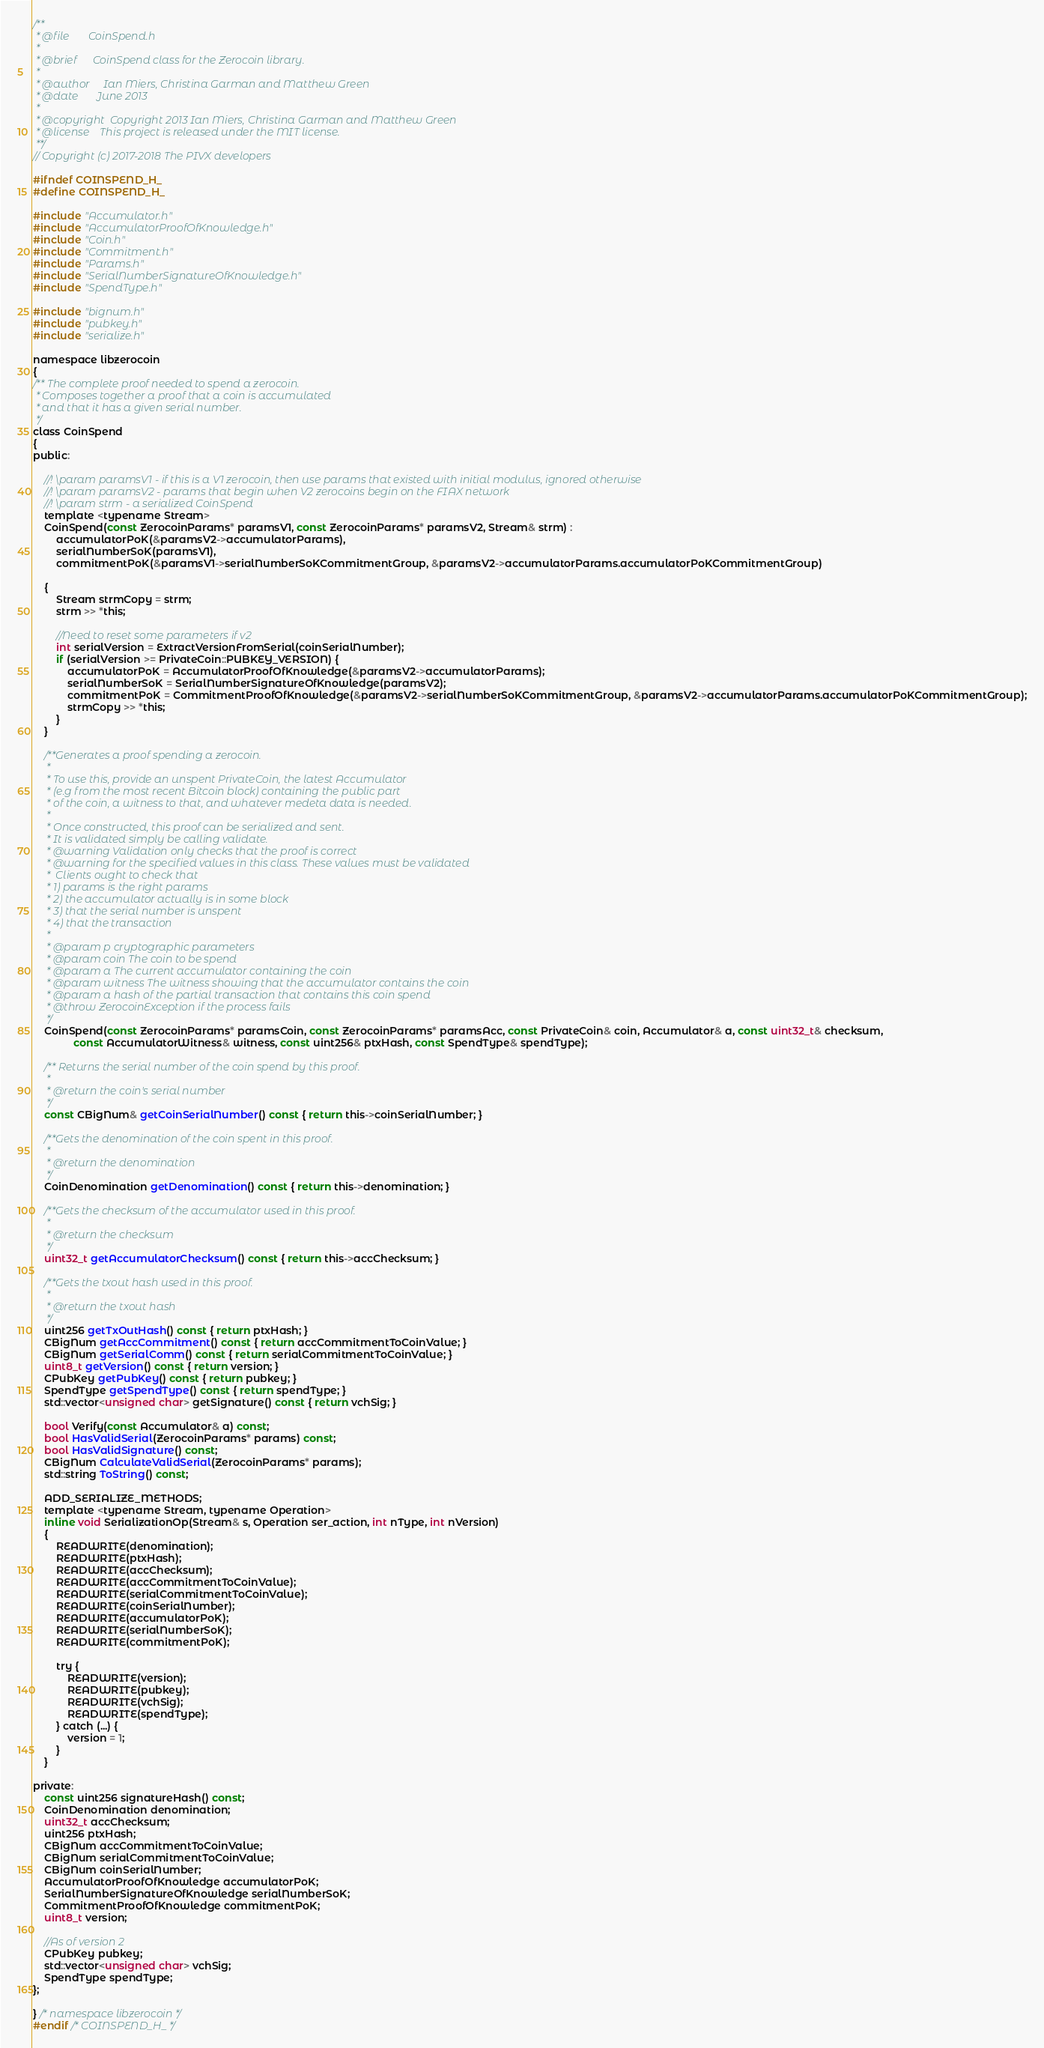Convert code to text. <code><loc_0><loc_0><loc_500><loc_500><_C_>/**
 * @file       CoinSpend.h
 *
 * @brief      CoinSpend class for the Zerocoin library.
 *
 * @author     Ian Miers, Christina Garman and Matthew Green
 * @date       June 2013
 *
 * @copyright  Copyright 2013 Ian Miers, Christina Garman and Matthew Green
 * @license    This project is released under the MIT license.
 **/
// Copyright (c) 2017-2018 The PIVX developers

#ifndef COINSPEND_H_
#define COINSPEND_H_

#include "Accumulator.h"
#include "AccumulatorProofOfKnowledge.h"
#include "Coin.h"
#include "Commitment.h"
#include "Params.h"
#include "SerialNumberSignatureOfKnowledge.h"
#include "SpendType.h"

#include "bignum.h"
#include "pubkey.h"
#include "serialize.h"

namespace libzerocoin
{
/** The complete proof needed to spend a zerocoin.
 * Composes together a proof that a coin is accumulated
 * and that it has a given serial number.
 */
class CoinSpend
{
public:

    //! \param paramsV1 - if this is a V1 zerocoin, then use params that existed with initial modulus, ignored otherwise
    //! \param paramsV2 - params that begin when V2 zerocoins begin on the FIAX network
    //! \param strm - a serialized CoinSpend
    template <typename Stream>
    CoinSpend(const ZerocoinParams* paramsV1, const ZerocoinParams* paramsV2, Stream& strm) :
        accumulatorPoK(&paramsV2->accumulatorParams),
        serialNumberSoK(paramsV1),
        commitmentPoK(&paramsV1->serialNumberSoKCommitmentGroup, &paramsV2->accumulatorParams.accumulatorPoKCommitmentGroup)

    {
        Stream strmCopy = strm;
        strm >> *this;

        //Need to reset some parameters if v2
        int serialVersion = ExtractVersionFromSerial(coinSerialNumber);
        if (serialVersion >= PrivateCoin::PUBKEY_VERSION) {
            accumulatorPoK = AccumulatorProofOfKnowledge(&paramsV2->accumulatorParams);
            serialNumberSoK = SerialNumberSignatureOfKnowledge(paramsV2);
            commitmentPoK = CommitmentProofOfKnowledge(&paramsV2->serialNumberSoKCommitmentGroup, &paramsV2->accumulatorParams.accumulatorPoKCommitmentGroup);
            strmCopy >> *this;
        }
    }

    /**Generates a proof spending a zerocoin.
	 *
	 * To use this, provide an unspent PrivateCoin, the latest Accumulator
	 * (e.g from the most recent Bitcoin block) containing the public part
	 * of the coin, a witness to that, and whatever medeta data is needed.
	 *
	 * Once constructed, this proof can be serialized and sent.
	 * It is validated simply be calling validate.
	 * @warning Validation only checks that the proof is correct
	 * @warning for the specified values in this class. These values must be validated
	 *  Clients ought to check that
	 * 1) params is the right params
	 * 2) the accumulator actually is in some block
	 * 3) that the serial number is unspent
	 * 4) that the transaction
	 *
	 * @param p cryptographic parameters
	 * @param coin The coin to be spend
	 * @param a The current accumulator containing the coin
	 * @param witness The witness showing that the accumulator contains the coin
	 * @param a hash of the partial transaction that contains this coin spend
	 * @throw ZerocoinException if the process fails
	 */
    CoinSpend(const ZerocoinParams* paramsCoin, const ZerocoinParams* paramsAcc, const PrivateCoin& coin, Accumulator& a, const uint32_t& checksum,
              const AccumulatorWitness& witness, const uint256& ptxHash, const SpendType& spendType);

    /** Returns the serial number of the coin spend by this proof.
	 *
	 * @return the coin's serial number
	 */
    const CBigNum& getCoinSerialNumber() const { return this->coinSerialNumber; }

    /**Gets the denomination of the coin spent in this proof.
	 *
	 * @return the denomination
	 */
    CoinDenomination getDenomination() const { return this->denomination; }

    /**Gets the checksum of the accumulator used in this proof.
	 *
	 * @return the checksum
	 */
    uint32_t getAccumulatorChecksum() const { return this->accChecksum; }

    /**Gets the txout hash used in this proof.
	 *
	 * @return the txout hash
	 */
    uint256 getTxOutHash() const { return ptxHash; }
    CBigNum getAccCommitment() const { return accCommitmentToCoinValue; }
    CBigNum getSerialComm() const { return serialCommitmentToCoinValue; }
    uint8_t getVersion() const { return version; }
    CPubKey getPubKey() const { return pubkey; }
    SpendType getSpendType() const { return spendType; }
    std::vector<unsigned char> getSignature() const { return vchSig; }

    bool Verify(const Accumulator& a) const;
    bool HasValidSerial(ZerocoinParams* params) const;
    bool HasValidSignature() const;
    CBigNum CalculateValidSerial(ZerocoinParams* params);
    std::string ToString() const;

    ADD_SERIALIZE_METHODS;
    template <typename Stream, typename Operation>
    inline void SerializationOp(Stream& s, Operation ser_action, int nType, int nVersion)
    {
        READWRITE(denomination);
        READWRITE(ptxHash);
        READWRITE(accChecksum);
        READWRITE(accCommitmentToCoinValue);
        READWRITE(serialCommitmentToCoinValue);
        READWRITE(coinSerialNumber);
        READWRITE(accumulatorPoK);
        READWRITE(serialNumberSoK);
        READWRITE(commitmentPoK);

        try {
            READWRITE(version);
            READWRITE(pubkey);
            READWRITE(vchSig);
            READWRITE(spendType);
        } catch (...) {
            version = 1;
        }
    }

private:
    const uint256 signatureHash() const;
    CoinDenomination denomination;
    uint32_t accChecksum;
    uint256 ptxHash;
    CBigNum accCommitmentToCoinValue;
    CBigNum serialCommitmentToCoinValue;
    CBigNum coinSerialNumber;
    AccumulatorProofOfKnowledge accumulatorPoK;
    SerialNumberSignatureOfKnowledge serialNumberSoK;
    CommitmentProofOfKnowledge commitmentPoK;
    uint8_t version;

    //As of version 2
    CPubKey pubkey;
    std::vector<unsigned char> vchSig;
    SpendType spendType;
};

} /* namespace libzerocoin */
#endif /* COINSPEND_H_ */
</code> 